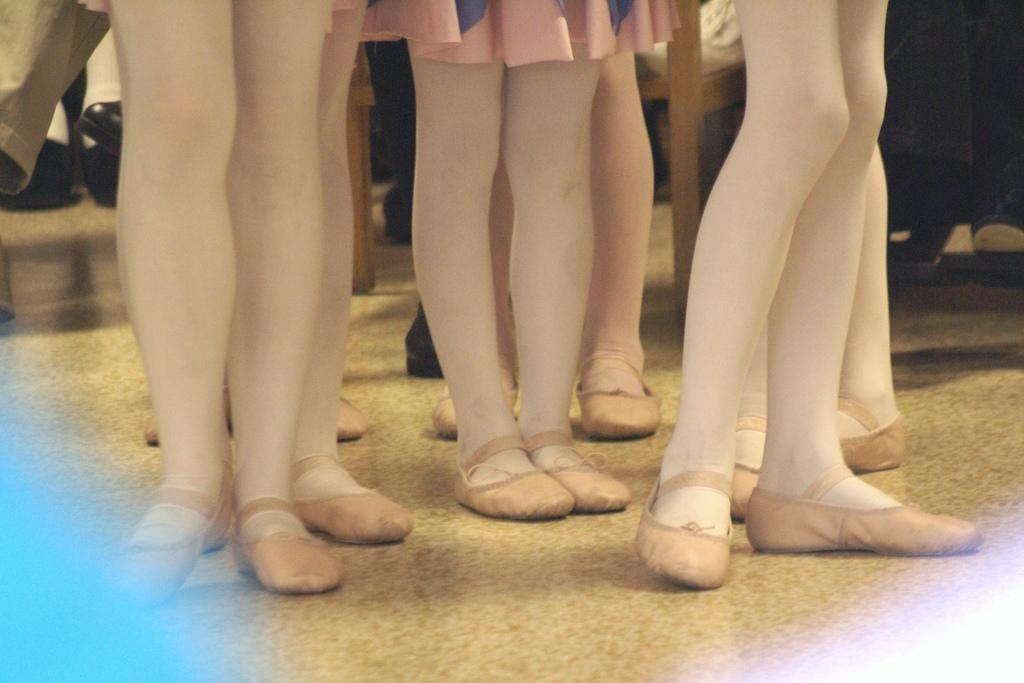What is the main subject of the image? The main subject of the image is a group of people standing in the center. What are the people wearing on their feet? The people are wearing shoes. Can you describe any furniture in the image? Yes, there is a chair present at the top of the image. What is the surface beneath the people's feet? The bottom of the image contains a floor. Can you see any family members swimming in the sea in the image? There is no sea or family members swimming in the image; it features a group of people standing and a chair. Is there a mountain visible in the background of the image? There is no mountain present in the image; it only contains a group of people, a chair, and a floor. 